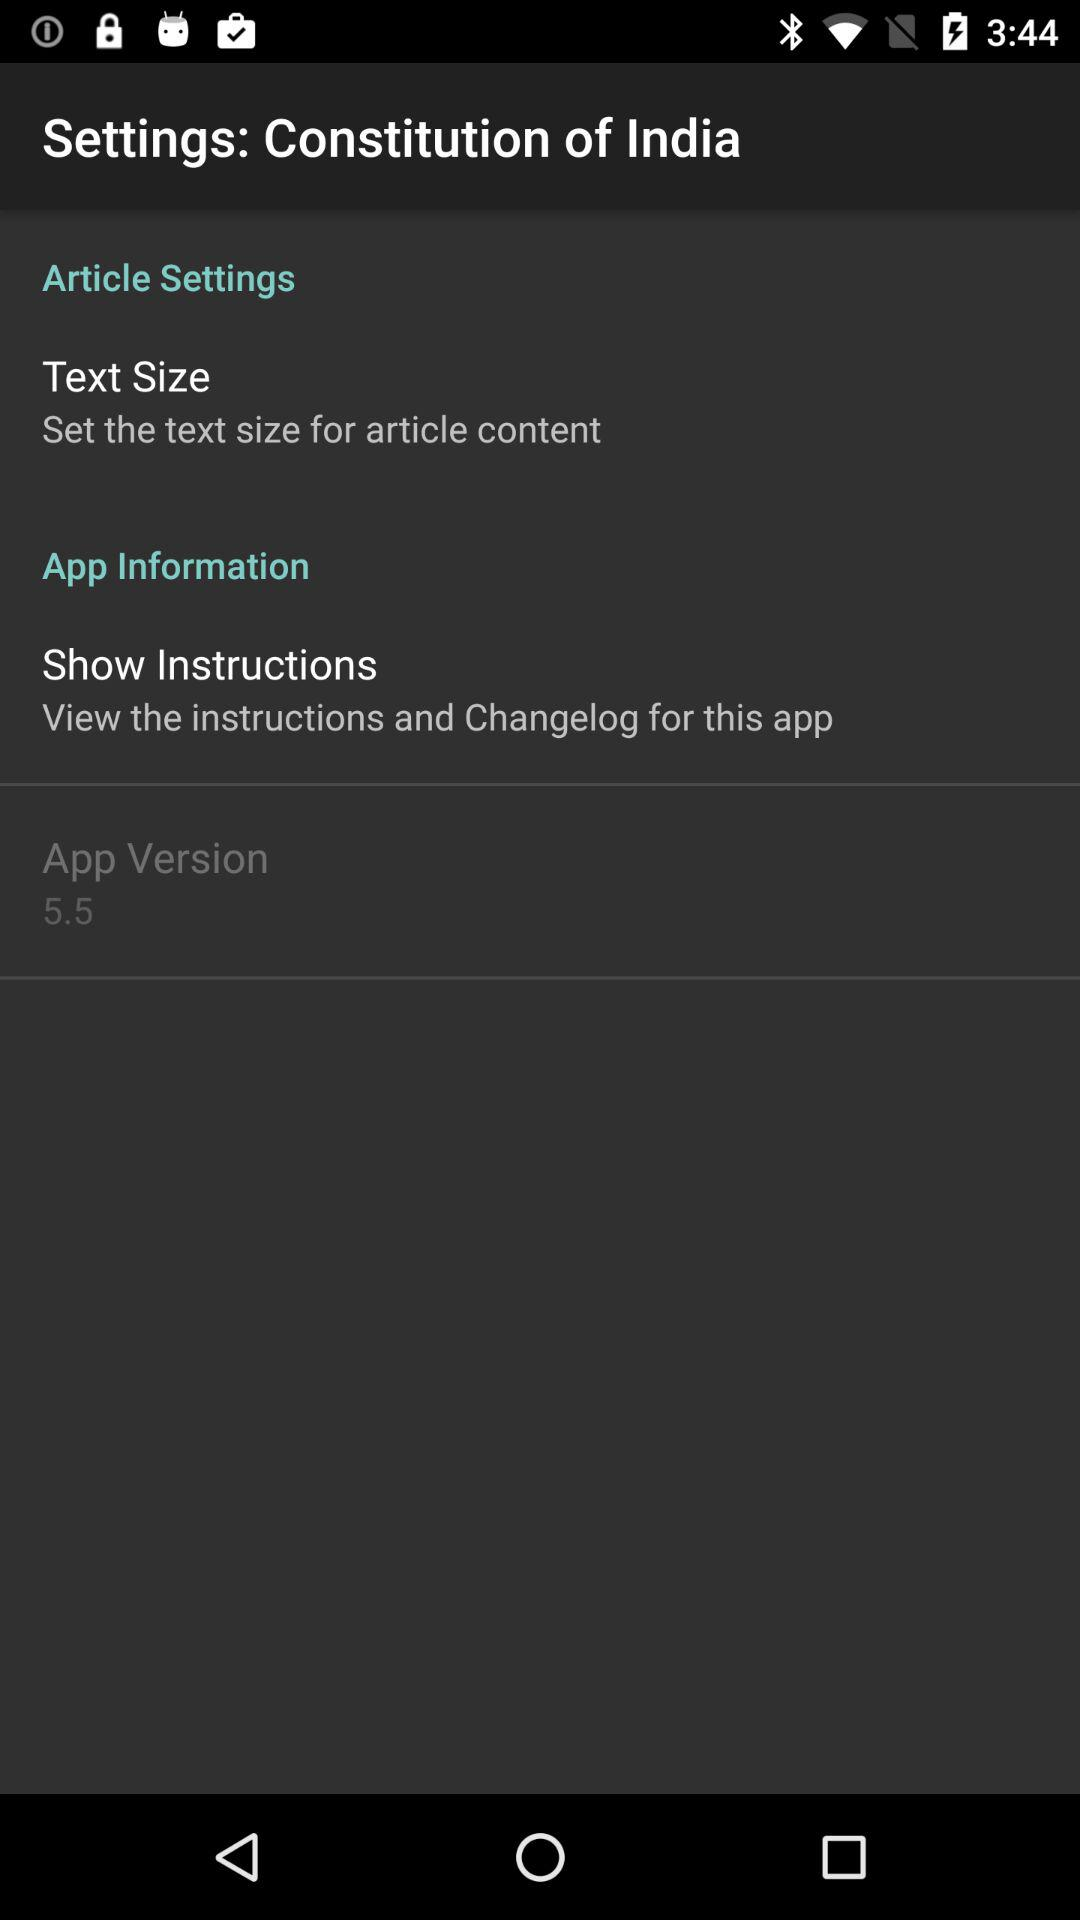What is the version of the application being used? The version of the application is 5.5. 